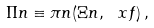<formula> <loc_0><loc_0><loc_500><loc_500>\Pi n \equiv \pi n ( \Xi n , \ x f ) \, ,</formula> 